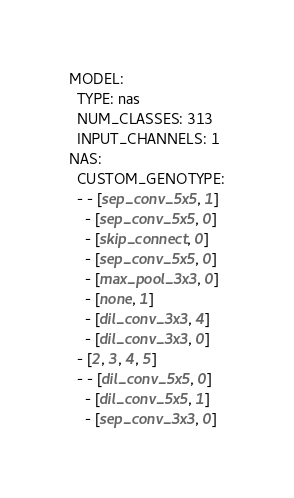<code> <loc_0><loc_0><loc_500><loc_500><_YAML_>MODEL:
  TYPE: nas
  NUM_CLASSES: 313
  INPUT_CHANNELS: 1
NAS:
  CUSTOM_GENOTYPE:
  - - [sep_conv_5x5, 1]
    - [sep_conv_5x5, 0]
    - [skip_connect, 0]
    - [sep_conv_5x5, 0]
    - [max_pool_3x3, 0]
    - [none, 1]
    - [dil_conv_3x3, 4]
    - [dil_conv_3x3, 0]
  - [2, 3, 4, 5]
  - - [dil_conv_5x5, 0]
    - [dil_conv_5x5, 1]
    - [sep_conv_3x3, 0]</code> 